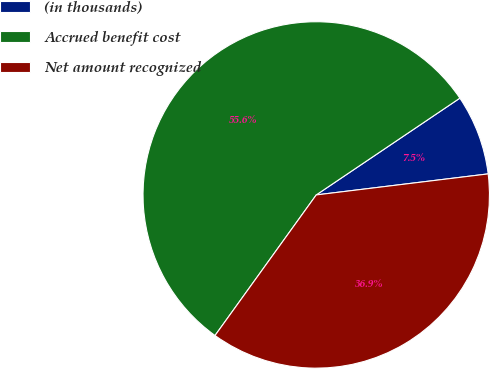<chart> <loc_0><loc_0><loc_500><loc_500><pie_chart><fcel>(in thousands)<fcel>Accrued benefit cost<fcel>Net amount recognized<nl><fcel>7.5%<fcel>55.63%<fcel>36.87%<nl></chart> 